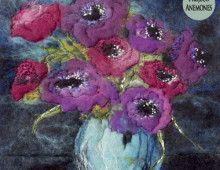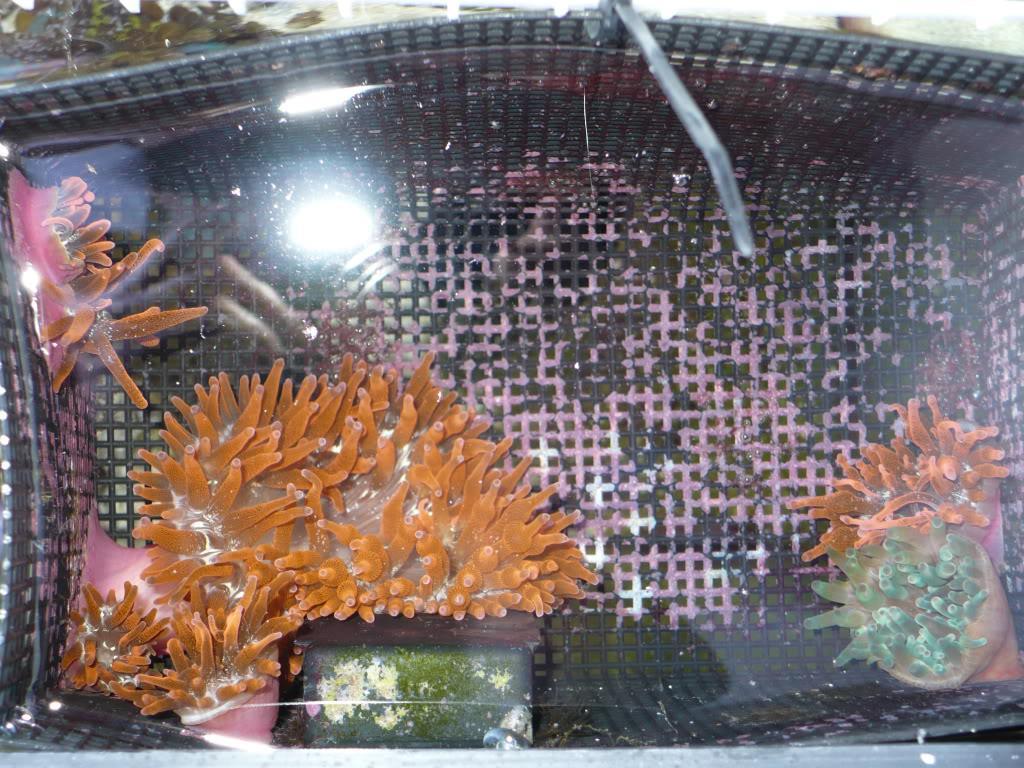The first image is the image on the left, the second image is the image on the right. Considering the images on both sides, is "In the image on the right, sea anemones rest in a container with holes in it." valid? Answer yes or no. Yes. 